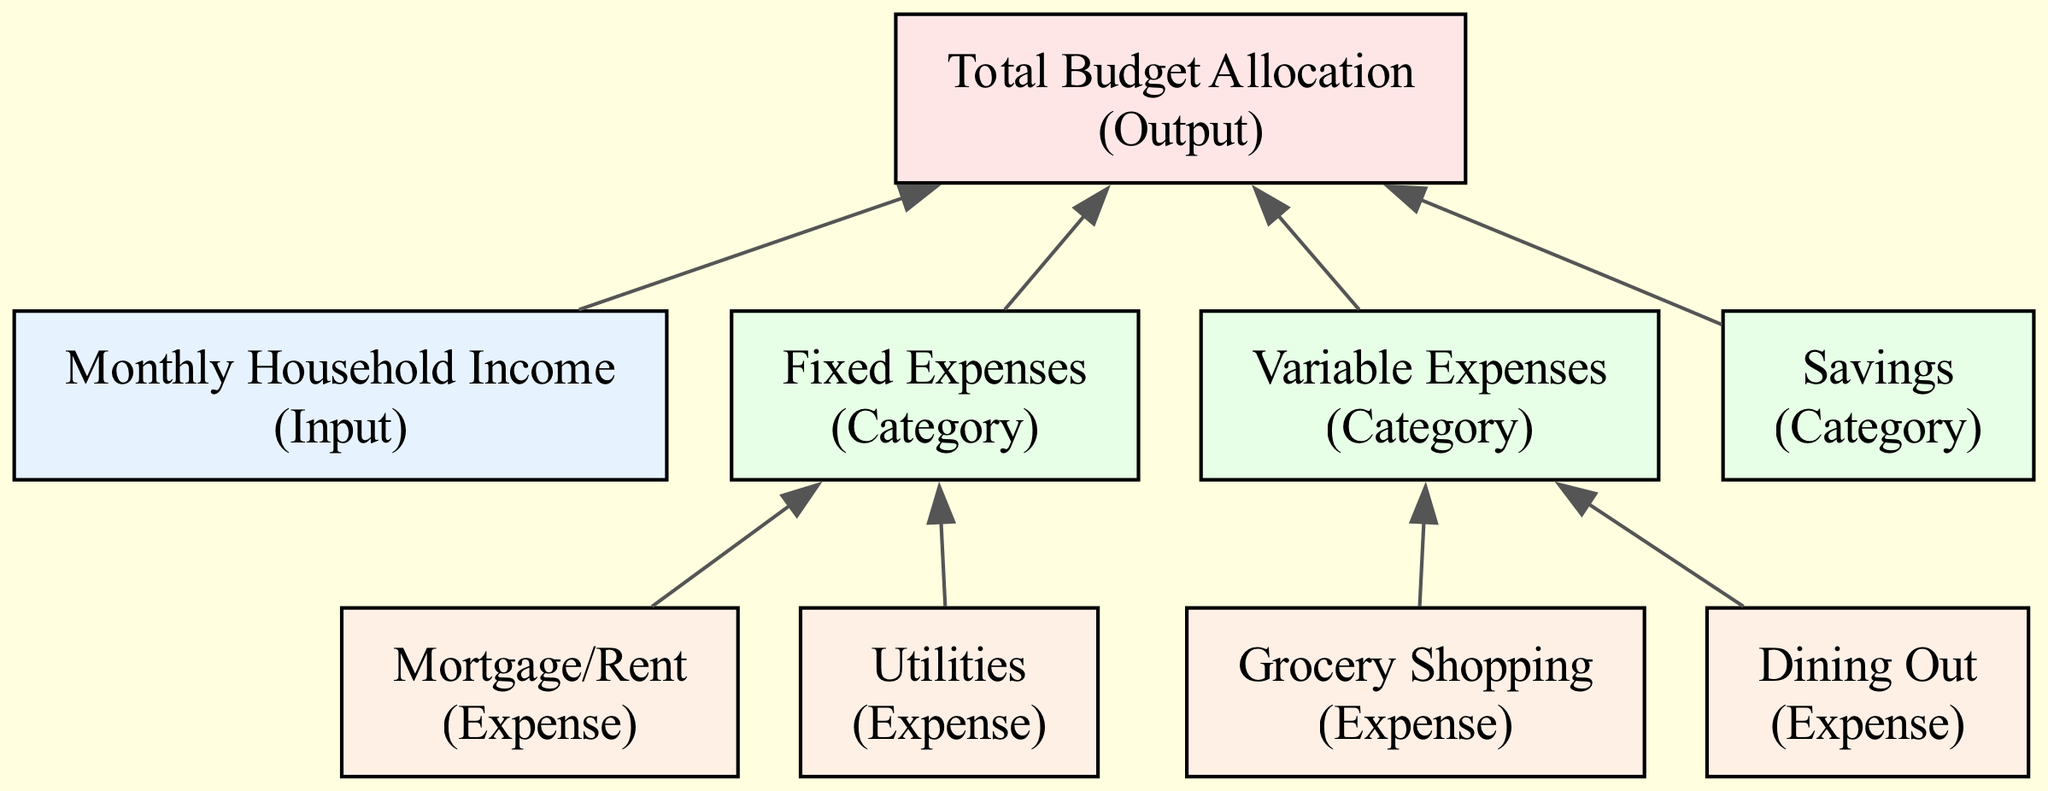What is the total number of main categories in the diagram? The diagram includes three main categories: Fixed Expenses, Variable Expenses, and Savings. Counting these categories gives us a total of three.
Answer: 3 What are the two subcategories under Fixed Expenses? Upon examining the Fixed Expenses category, the subcategories listed are Mortgage/Rent and Utilities. These represent essential monthly expenses.
Answer: Mortgage/Rent and Utilities Which category does Grocery Shopping fall under? The Grocery Shopping expense is listed as a subcategory under the Variable Expenses category. This indicates it can vary from month to month.
Answer: Variable Expenses How many total expenses are mentioned in the diagram? The diagram includes four expense nodes: Mortgage/Rent, Utilities, Grocery Shopping, and Dining Out. Adding these gives a total of four expenses.
Answer: 4 What is the relationship between Fixed Expenses and Total Budget Allocation? The diagram shows an edge connecting Fixed Expenses to Total Budget Allocation, indicating that Fixed Expenses contribute to the overall budget allocation calculation.
Answer: Contribution What is the type of the node Monthly Household Income? The node Monthly Household Income is classified as an Input type. This means it represents the initial resource available for budgeting.
Answer: Input Which two categories are connected to Total Budget Allocation? Both Fixed Expenses and Variable Expenses categories are connected to the Total Budget Allocation node, indicating that both these categories contribute to the final allocation of the budget.
Answer: Fixed Expenses and Variable Expenses How is the color scheme used to differentiate between node types? The diagram uses specific colors to represent different types of nodes: blue for Input, red for Output, green for Category, and orange for Expense. This color-coding helps to quickly identify the roles of each node.
Answer: Color coding Which category has the most subcategories? The Variable Expenses category has two subcategories: Grocery Shopping and Dining Out, making it the only category with more than one subcategory. Thus, it has the most subcategories in the diagram.
Answer: Variable Expenses 